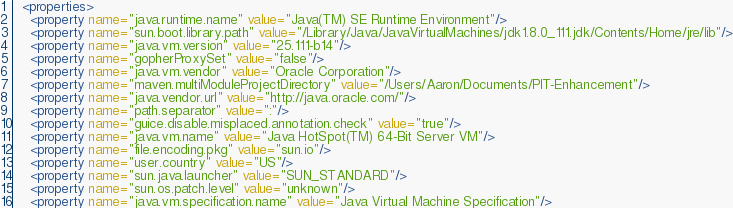<code> <loc_0><loc_0><loc_500><loc_500><_XML_>  <properties>
    <property name="java.runtime.name" value="Java(TM) SE Runtime Environment"/>
    <property name="sun.boot.library.path" value="/Library/Java/JavaVirtualMachines/jdk1.8.0_111.jdk/Contents/Home/jre/lib"/>
    <property name="java.vm.version" value="25.111-b14"/>
    <property name="gopherProxySet" value="false"/>
    <property name="java.vm.vendor" value="Oracle Corporation"/>
    <property name="maven.multiModuleProjectDirectory" value="/Users/Aaron/Documents/PIT-Enhancement"/>
    <property name="java.vendor.url" value="http://java.oracle.com/"/>
    <property name="path.separator" value=":"/>
    <property name="guice.disable.misplaced.annotation.check" value="true"/>
    <property name="java.vm.name" value="Java HotSpot(TM) 64-Bit Server VM"/>
    <property name="file.encoding.pkg" value="sun.io"/>
    <property name="user.country" value="US"/>
    <property name="sun.java.launcher" value="SUN_STANDARD"/>
    <property name="sun.os.patch.level" value="unknown"/>
    <property name="java.vm.specification.name" value="Java Virtual Machine Specification"/></code> 